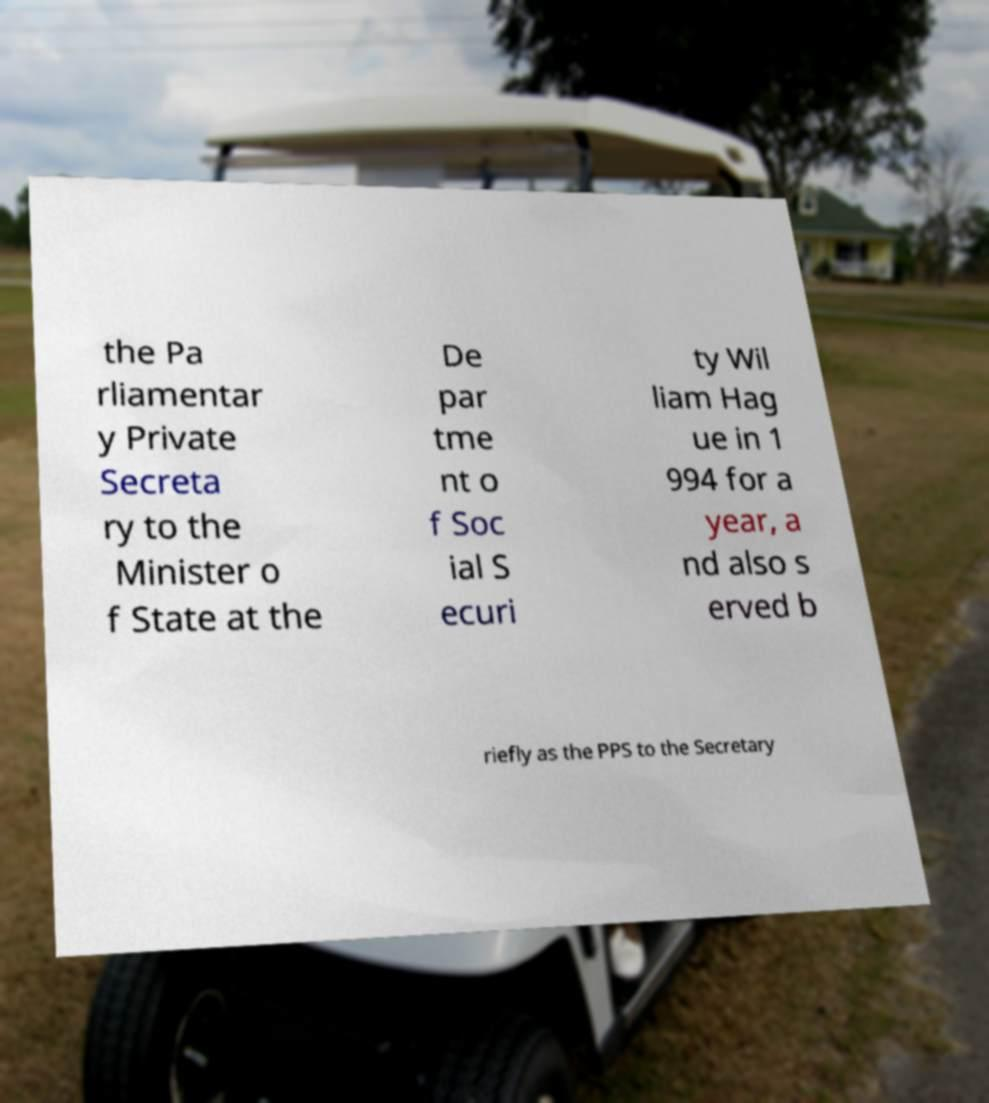Could you assist in decoding the text presented in this image and type it out clearly? the Pa rliamentar y Private Secreta ry to the Minister o f State at the De par tme nt o f Soc ial S ecuri ty Wil liam Hag ue in 1 994 for a year, a nd also s erved b riefly as the PPS to the Secretary 